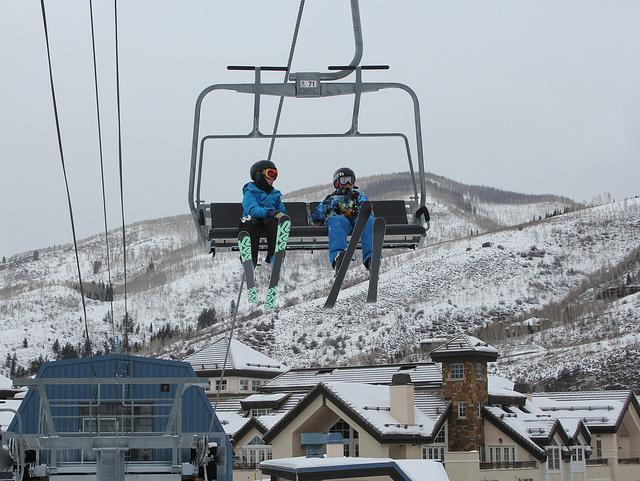Which comparative elevation do the seated people wish for? Please explain your reasoning. higher. They are wearing skis. skiers start from the top of a hill. 